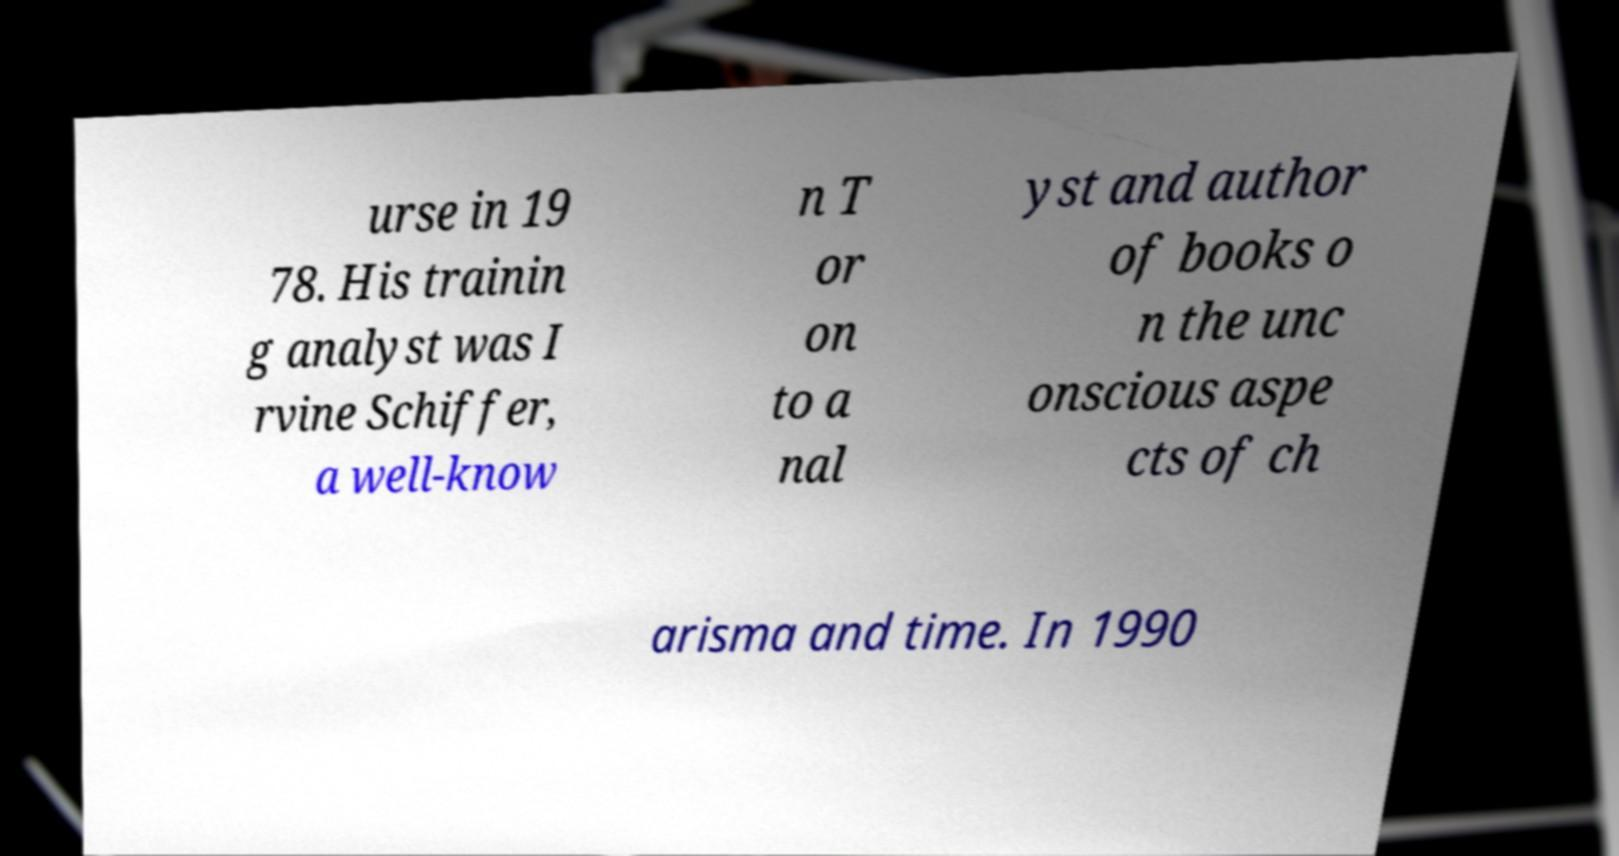Can you read and provide the text displayed in the image?This photo seems to have some interesting text. Can you extract and type it out for me? urse in 19 78. His trainin g analyst was I rvine Schiffer, a well-know n T or on to a nal yst and author of books o n the unc onscious aspe cts of ch arisma and time. In 1990 